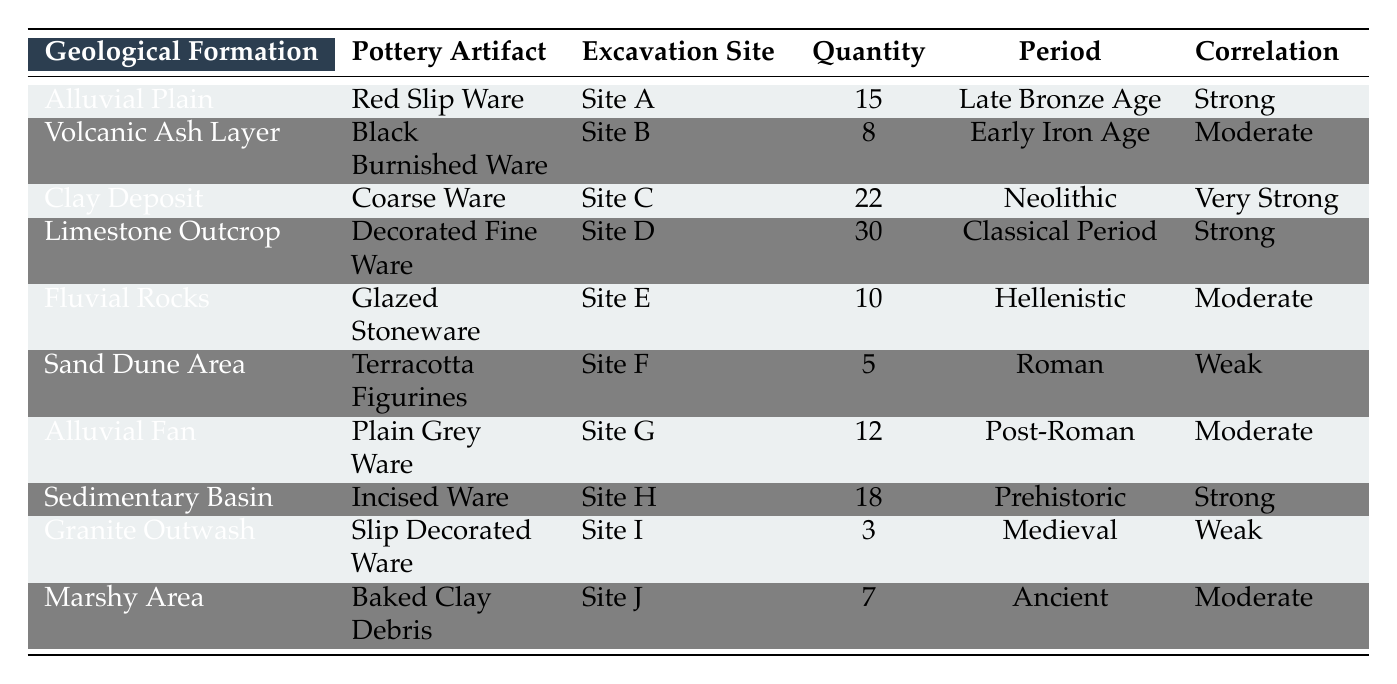What pottery artifact was found in the Clay Deposit formation? The table indicates that the pottery artifact found in the Clay Deposit formation is Coarse Ware.
Answer: Coarse Ware How many pottery artifacts were found at Site D? According to the table, there were 30 artifacts found at Site D, which corresponds to the Limestone Outcrop geological formation and the Decorated Fine Ware.
Answer: 30 What is the total quantity of pottery artifacts found in the Alluvial Plain and Alluvial Fan? For the Alluvial Plain, there are 15 artifacts (Red Slip Ware), and for the Alluvial Fan, there are 12 artifacts (Plain Grey Ware). Adding these together gives 15 + 12 = 27.
Answer: 27 Is there a correlation between the geological formation of Granite Outwash and the quantity of artifacts found? The table shows a weak correlation between the Granite Outwash formation and the pottery artifacts found, which is corroborated by the data given for that row.
Answer: Yes What is the average quantity of pottery artifacts found in excavation sites with a strong correlation? There are two sites with strong correlation: Site A (15 artifacts) and Site D (30 artifacts). The total quantity is 15 + 30 = 45, and there are 2 sites, so the average is 45 / 2 = 22.5.
Answer: 22.5 How many excavation sites found pottery artifacts from the Roman period? The table lists Site F (Terracotta Figurines) as the only site with pottery artifacts found from the Roman period, indicating there is 1 site.
Answer: 1 What pottery artifact corresponds to the Sedimentary Basin formation? The table indicates that the pottery artifact corresponding to the Sedimentary Basin formation is Incised Ware.
Answer: Incised Ware How many different geological formations are represented in the table? By counting the unique geological formations listed in the table, we find a total of 10 different formations: Alluvial Plain, Volcanic Ash Layer, Clay Deposit, Limestone Outcrop, Fluvial Rocks, Sand Dune Area, Alluvial Fan, Sedimentary Basin, Granite Outwash, and Marshy Area.
Answer: 10 